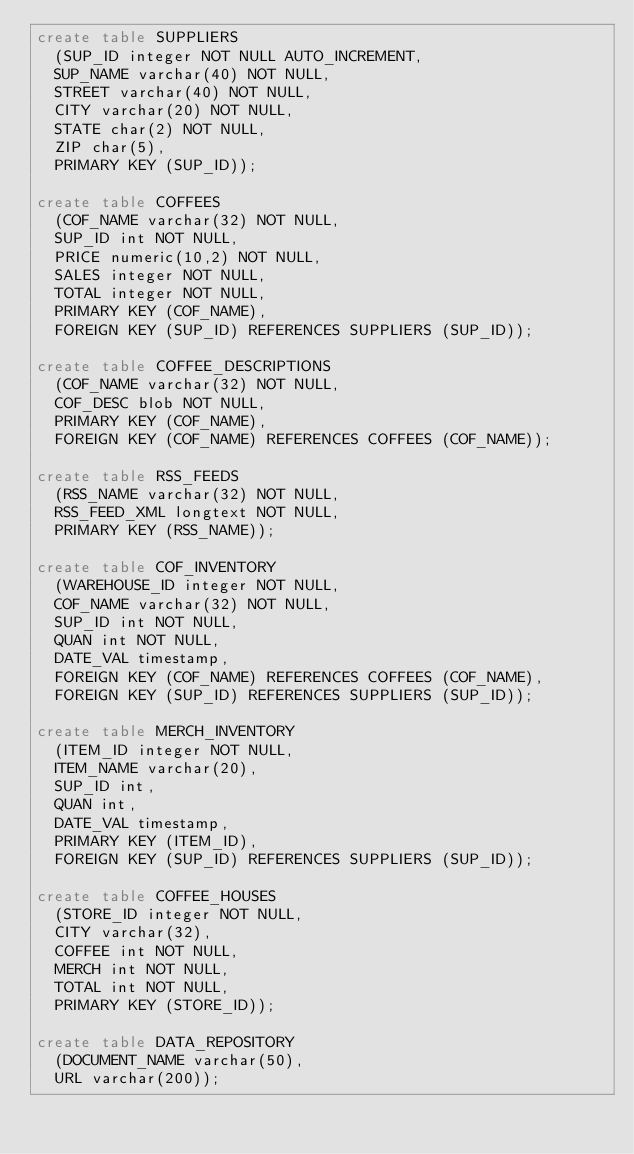Convert code to text. <code><loc_0><loc_0><loc_500><loc_500><_SQL_>create table SUPPLIERS
  (SUP_ID integer NOT NULL AUTO_INCREMENT,
  SUP_NAME varchar(40) NOT NULL,
  STREET varchar(40) NOT NULL,
  CITY varchar(20) NOT NULL,
  STATE char(2) NOT NULL,
  ZIP char(5),
  PRIMARY KEY (SUP_ID));
  
create table COFFEES
  (COF_NAME varchar(32) NOT NULL,
  SUP_ID int NOT NULL,
  PRICE numeric(10,2) NOT NULL,
  SALES integer NOT NULL,
  TOTAL integer NOT NULL,
  PRIMARY KEY (COF_NAME),
  FOREIGN KEY (SUP_ID) REFERENCES SUPPLIERS (SUP_ID));
  
create table COFFEE_DESCRIPTIONS
  (COF_NAME varchar(32) NOT NULL,
  COF_DESC blob NOT NULL,
  PRIMARY KEY (COF_NAME),
  FOREIGN KEY (COF_NAME) REFERENCES COFFEES (COF_NAME));

create table RSS_FEEDS
  (RSS_NAME varchar(32) NOT NULL,
  RSS_FEED_XML longtext NOT NULL,
  PRIMARY KEY (RSS_NAME));
  
create table COF_INVENTORY
  (WAREHOUSE_ID integer NOT NULL,
  COF_NAME varchar(32) NOT NULL,
  SUP_ID int NOT NULL,
  QUAN int NOT NULL,
  DATE_VAL timestamp,
  FOREIGN KEY (COF_NAME) REFERENCES COFFEES (COF_NAME),
  FOREIGN KEY (SUP_ID) REFERENCES SUPPLIERS (SUP_ID));
  
create table MERCH_INVENTORY
  (ITEM_ID integer NOT NULL,
  ITEM_NAME varchar(20),
  SUP_ID int,
  QUAN int,
  DATE_VAL timestamp,
  PRIMARY KEY (ITEM_ID),
  FOREIGN KEY (SUP_ID) REFERENCES SUPPLIERS (SUP_ID));
  
create table COFFEE_HOUSES
  (STORE_ID integer NOT NULL,
  CITY varchar(32),
  COFFEE int NOT NULL,
  MERCH int NOT NULL,
  TOTAL int NOT NULL,
  PRIMARY KEY (STORE_ID));
  
create table DATA_REPOSITORY
  (DOCUMENT_NAME varchar(50),
  URL varchar(200));</code> 